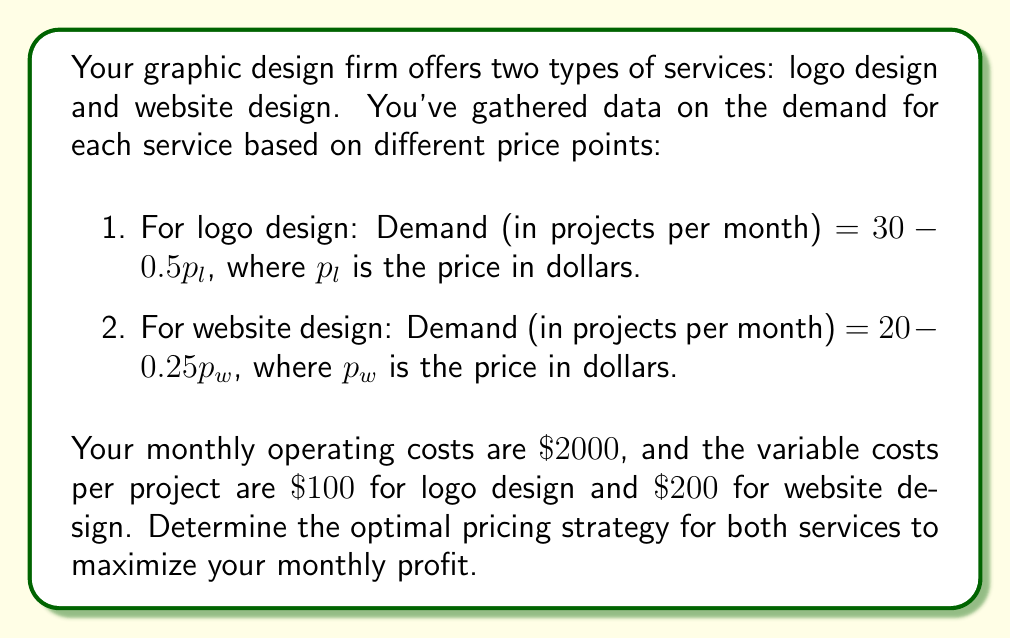Can you answer this question? Let's approach this step-by-step:

1) First, let's define our variables:
   $p_l$ = price of logo design
   $p_w$ = price of website design
   $q_l$ = quantity of logo design projects (demand)
   $q_w$ = quantity of website design projects (demand)

2) We can express the demand equations:
   $q_l = 30 - 0.5p_l$
   $q_w = 20 - 0.25p_w$

3) Now, let's create a profit function. Profit = Revenue - Costs
   Profit = $(p_l q_l + p_w q_w) - (2000 + 100q_l + 200q_w)$

4) Substitute the demand equations:
   Profit = $p_l(30 - 0.5p_l) + p_w(20 - 0.25p_w) - 2000 - 100(30 - 0.5p_l) - 200(20 - 0.25p_w)$

5) Simplify:
   Profit = $30p_l - 0.5p_l^2 + 20p_w - 0.25p_w^2 - 2000 - 3000 + 50p_l - 4000 + 50p_w$
   Profit = $-0.5p_l^2 + 80p_l - 0.25p_w^2 + 70p_w - 9000$

6) To maximize profit, we need to find where the partial derivatives with respect to $p_l$ and $p_w$ are zero:

   $\frac{\partial \text{Profit}}{\partial p_l} = -p_l + 80 = 0$
   $\frac{\partial \text{Profit}}{\partial p_w} = -0.5p_w + 70 = 0$

7) Solve these equations:
   $p_l = 80$
   $p_w = 140$

8) Verify that this is a maximum by checking the second derivatives (they should be negative):
   $\frac{\partial^2 \text{Profit}}{\partial p_l^2} = -1 < 0$
   $\frac{\partial^2 \text{Profit}}{\partial p_w^2} = -0.5 < 0$

9) Calculate the quantities at these prices:
   $q_l = 30 - 0.5(80) = 10$
   $q_w = 20 - 0.25(140) = 15$

10) Calculate the maximum profit:
    Profit = $80(10) + 140(15) - 2000 - 100(10) - 200(15) = 800 + 2100 - 2000 - 1000 - 3000 = -1100$

Therefore, the optimal pricing strategy is to charge $\$80$ for logo design and $\$140$ for website design.
Answer: $p_l = \$80, p_w = \$140$ 